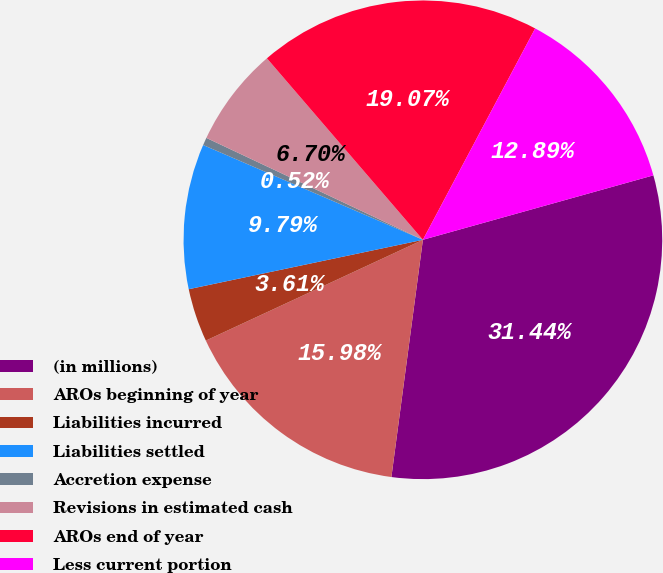<chart> <loc_0><loc_0><loc_500><loc_500><pie_chart><fcel>(in millions)<fcel>AROs beginning of year<fcel>Liabilities incurred<fcel>Liabilities settled<fcel>Accretion expense<fcel>Revisions in estimated cash<fcel>AROs end of year<fcel>Less current portion<nl><fcel>31.44%<fcel>15.98%<fcel>3.61%<fcel>9.79%<fcel>0.52%<fcel>6.7%<fcel>19.07%<fcel>12.89%<nl></chart> 